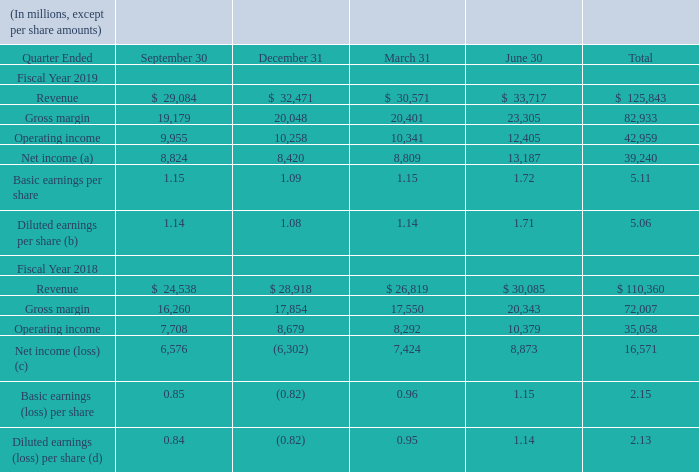NOTE 21 — QUARTERLY INFORMATION (UNAUDITED)
(a) Reflects the $157 million net charge related to the enactment of the TCJA for the second quarter and the $2.6 billion net income tax benefit related to the intangible property transfers for the fourth quarter, which together increased net income by $2.4 billion for fiscal year 2019. See Note 12 – Income Taxes for further information.
(b) Reflects the net charge related to the enactment of the TCJA and the net income tax benefit related to the intangible property transfers, which decreased (increased) diluted EPS $0.02 for the second quarter, $(0.34) for the fourth quarter, and $(0.31) for fiscal year 2019.
(c) Reflects the net charge (benefit) related to the enactment of the TCJA of $13.8 billion for the second quarter, $(104) million for the fourth quarter, and $13.7 billion for fiscal year 2018.
(d) Reflects the net charge (benefit) related to the enactment of the TCJA, which decreased (increased) diluted EPS $1.78 for the second quarter, $(0.01) for the fourth quarter, and $1.75 for fiscal year 2018.
What does Note 12 cover? Income taxes. How much was the net charge related to the enactment of the TCJA for the second quarter? $157 million net charge related to the enactment of the tcja for the second quarter. What does Note 21 cover? Quarterly information (unaudited). Which quarter ended in fiscal year 2019 saw the highest revenue? 33,717 > 32,471 > 30,571 > 29,084
Answer: june 30. How much would diluted EPS be for second quarter ended of fiscal year 2019 without the net charge related to the enactment of the TCJA and the net income tax benefit related to the intangible property transfers? 1.71+0.02
Answer: 1.73. How much would diluted earnings per share for fiscal year 2018 be without the net charge (benefit) related to the enactment of the TCJA? 2.13+1.75
Answer: 3.88. 